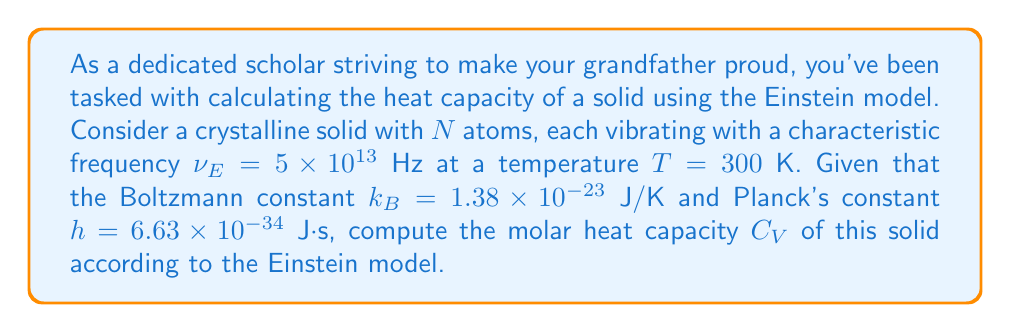Teach me how to tackle this problem. Let's approach this step-by-step:

1) The Einstein model gives the molar heat capacity $C_V$ as:

   $$C_V = 3R \left(\frac{\theta_E}{T}\right)^2 \frac{e^{\theta_E/T}}{(e^{\theta_E/T}-1)^2}$$

   where $R$ is the gas constant and $\theta_E$ is the Einstein temperature.

2) We need to calculate $\theta_E$ first:

   $$\theta_E = \frac{h\nu_E}{k_B}$$

3) Let's substitute the values:

   $$\theta_E = \frac{(6.63 \times 10^{-34} \text{ J⋅s})(5 \times 10^{13} \text{ Hz})}{1.38 \times 10^{-23} \text{ J/K}} = 240 \text{ K}$$

4) Now we can calculate $\theta_E/T$:

   $$\frac{\theta_E}{T} = \frac{240 \text{ K}}{300 \text{ K}} = 0.8$$

5) Substituting this into our heat capacity equation:

   $$C_V = 3R \left(0.8\right)^2 \frac{e^{0.8}}{(e^{0.8}-1)^2}$$

6) $R = 8.314$ J/(mol⋅K), so:

   $$C_V = 3(8.314) (0.64) \frac{2.2255}{(1.2255)^2}$$

7) Calculating this:

   $$C_V = 15.96 \text{ J/(mol⋅K)}$$

Therefore, the molar heat capacity of the solid is approximately 15.96 J/(mol⋅K).
Answer: $C_V = 15.96$ J/(mol⋅K) 